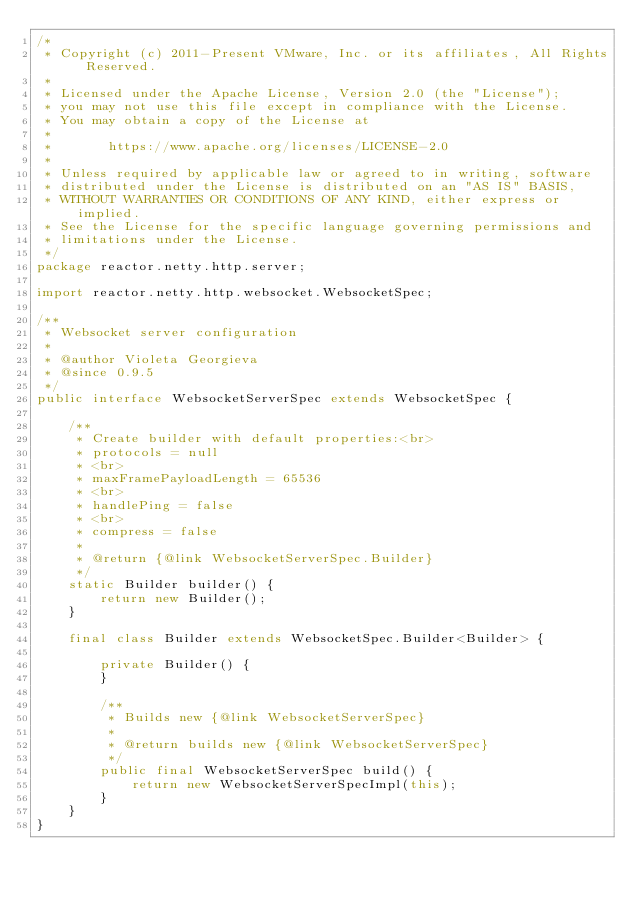Convert code to text. <code><loc_0><loc_0><loc_500><loc_500><_Java_>/*
 * Copyright (c) 2011-Present VMware, Inc. or its affiliates, All Rights Reserved.
 *
 * Licensed under the Apache License, Version 2.0 (the "License");
 * you may not use this file except in compliance with the License.
 * You may obtain a copy of the License at
 *
 *       https://www.apache.org/licenses/LICENSE-2.0
 *
 * Unless required by applicable law or agreed to in writing, software
 * distributed under the License is distributed on an "AS IS" BASIS,
 * WITHOUT WARRANTIES OR CONDITIONS OF ANY KIND, either express or implied.
 * See the License for the specific language governing permissions and
 * limitations under the License.
 */
package reactor.netty.http.server;

import reactor.netty.http.websocket.WebsocketSpec;

/**
 * Websocket server configuration
 *
 * @author Violeta Georgieva
 * @since 0.9.5
 */
public interface WebsocketServerSpec extends WebsocketSpec {

	/**
	 * Create builder with default properties:<br>
	 * protocols = null
	 * <br>
	 * maxFramePayloadLength = 65536
	 * <br>
	 * handlePing = false
	 * <br>
	 * compress = false
	 *
	 * @return {@link WebsocketServerSpec.Builder}
	 */
	static Builder builder() {
		return new Builder();
	}

	final class Builder extends WebsocketSpec.Builder<Builder> {

		private Builder() {
		}

		/**
		 * Builds new {@link WebsocketServerSpec}
		 *
		 * @return builds new {@link WebsocketServerSpec}
		 */
		public final WebsocketServerSpec build() {
			return new WebsocketServerSpecImpl(this);
		}
	}
}
</code> 